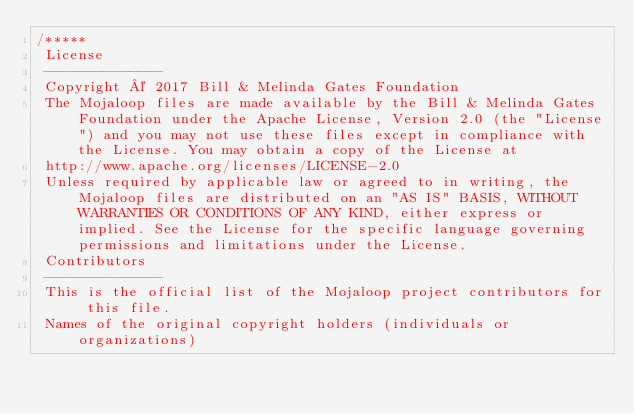<code> <loc_0><loc_0><loc_500><loc_500><_JavaScript_>/*****
 License
 --------------
 Copyright © 2017 Bill & Melinda Gates Foundation
 The Mojaloop files are made available by the Bill & Melinda Gates Foundation under the Apache License, Version 2.0 (the "License") and you may not use these files except in compliance with the License. You may obtain a copy of the License at
 http://www.apache.org/licenses/LICENSE-2.0
 Unless required by applicable law or agreed to in writing, the Mojaloop files are distributed on an "AS IS" BASIS, WITHOUT WARRANTIES OR CONDITIONS OF ANY KIND, either express or implied. See the License for the specific language governing permissions and limitations under the License.
 Contributors
 --------------
 This is the official list of the Mojaloop project contributors for this file.
 Names of the original copyright holders (individuals or organizations)</code> 